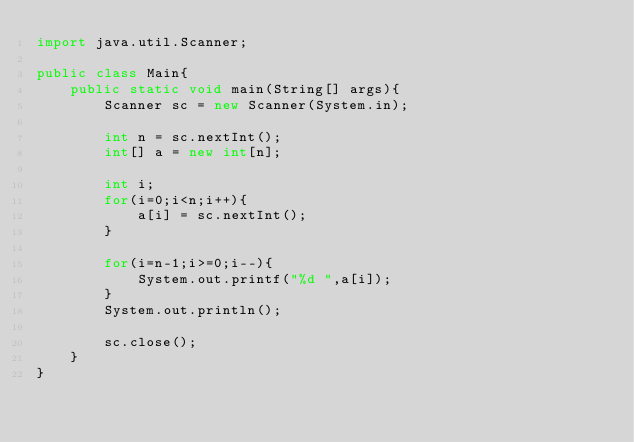<code> <loc_0><loc_0><loc_500><loc_500><_Java_>import java.util.Scanner;

public class Main{
    public static void main(String[] args){
        Scanner sc = new Scanner(System.in);

        int n = sc.nextInt();
        int[] a = new int[n];

        int i;
        for(i=0;i<n;i++){
            a[i] = sc.nextInt();
        }

        for(i=n-1;i>=0;i--){
            System.out.printf("%d ",a[i]);
        }
        System.out.println();

        sc.close();
    }
}
</code> 